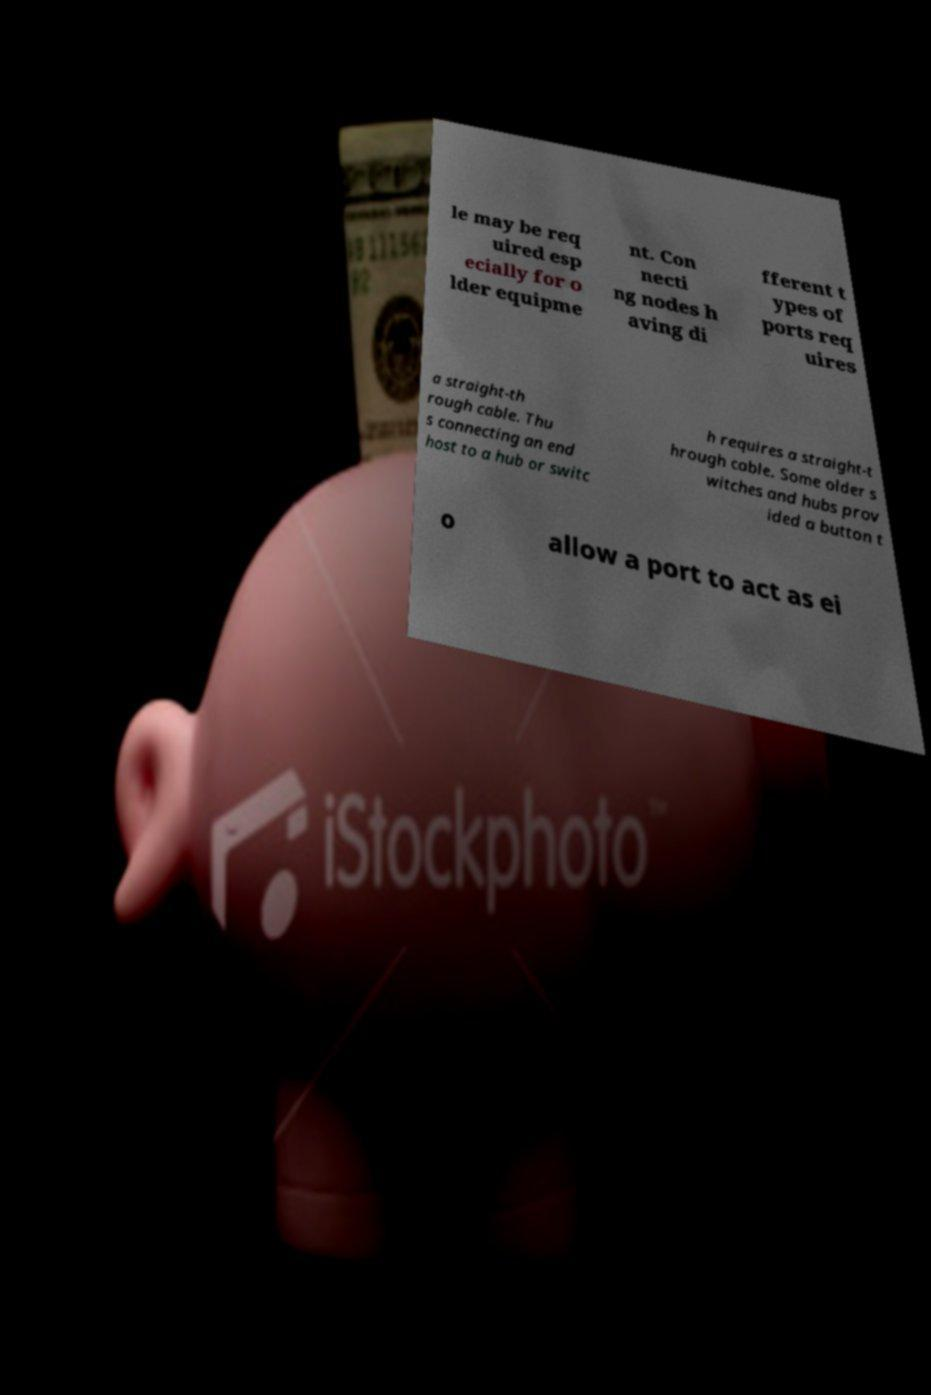Could you assist in decoding the text presented in this image and type it out clearly? le may be req uired esp ecially for o lder equipme nt. Con necti ng nodes h aving di fferent t ypes of ports req uires a straight-th rough cable. Thu s connecting an end host to a hub or switc h requires a straight-t hrough cable. Some older s witches and hubs prov ided a button t o allow a port to act as ei 